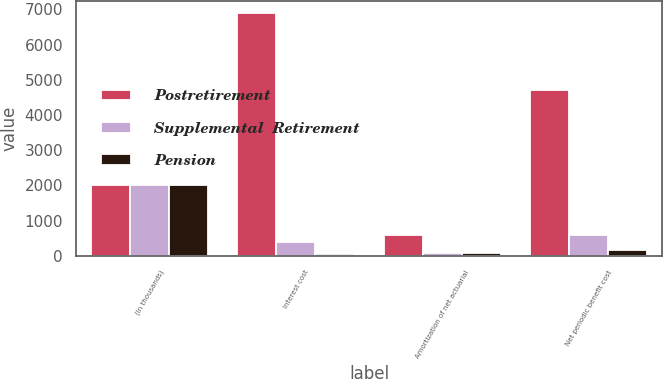Convert chart to OTSL. <chart><loc_0><loc_0><loc_500><loc_500><stacked_bar_chart><ecel><fcel>(In thousands)<fcel>Interest cost<fcel>Amortization of net actuarial<fcel>Net periodic benefit cost<nl><fcel>Postretirement<fcel>2013<fcel>6885<fcel>598<fcel>4722<nl><fcel>Supplemental  Retirement<fcel>2013<fcel>404<fcel>70<fcel>598<nl><fcel>Pension<fcel>2013<fcel>41<fcel>75<fcel>153<nl></chart> 